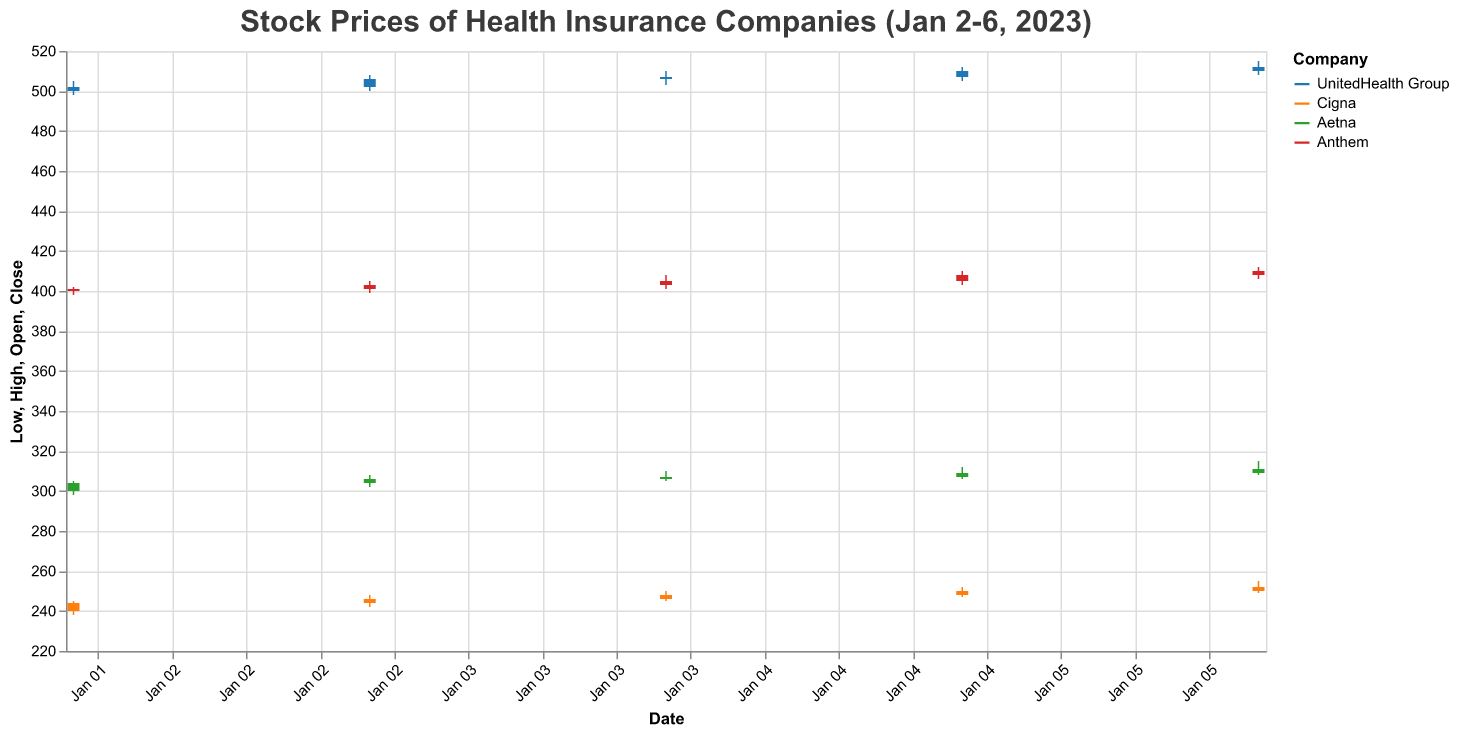What is the title of the figure? The title is displayed at the top of the figure, indicating the subject of the data visualized.
Answer: Stock Prices of Health Insurance Companies (Jan 2-6, 2023) How many companies are shown in the figure? The legend on the right side of the figure lists the companies included in the plot.
Answer: Four Which company had the highest closing price on January 6, 2023? By looking at the bar segments (representing closing prices) for January 6 across different companies, UnitedHealth Group has the highest closing value.
Answer: UnitedHealth Group What was the average closing price of Cigna over the 5-day period? Sum the closing prices of Cigna for each day (244 + 246 + 248 + 250 + 252) and then divide by the number of days (5). \( (244 + 246 + 248 + 250 + 252) / 5 = 248 \)
Answer: 248 Compare the opening and closing prices of Aetna on January 3, 2023. Did the stock close higher or lower than it opened? Look at the bar plot for Aetna on January 3. The bar representing January 3 closes higher than it opens.
Answer: Higher Which company experienced the largest price range on January 4, 2023? Calculate the price range (High-Low) for each company on January 4. UnitedHealth Group (510-503=7), Cigna (250-245=5), Aetna (310-305=5), Anthem (408-401=7)
Answer: UnitedHealth Group and Anthem What was the total volume traded for Anthem over the 5 days? Add the volume numbers for Anthem across all 5 days. \( 950,000 + 940,000 + 960,000 + 985,000 + 990,000 \)
Answer: 4,825,000 Which company showed a consistent increasing trend in closing prices over the week? By observing the trend in the heights of the bars representing the closing prices, Aetna shows a consistent increase.
Answer: Aetna What was the lowest closing price for UnitedHealth Group in the given days? Look at the lowest point of the closing price bars for UnitedHealth Group.
Answer: 502.00 Did any company have the same opening and closing price on any given day? Check the bars to see if the top part of the bar (close) aligns with the bottom part of the bar (open). None of the bars show this alignment.
Answer: No 